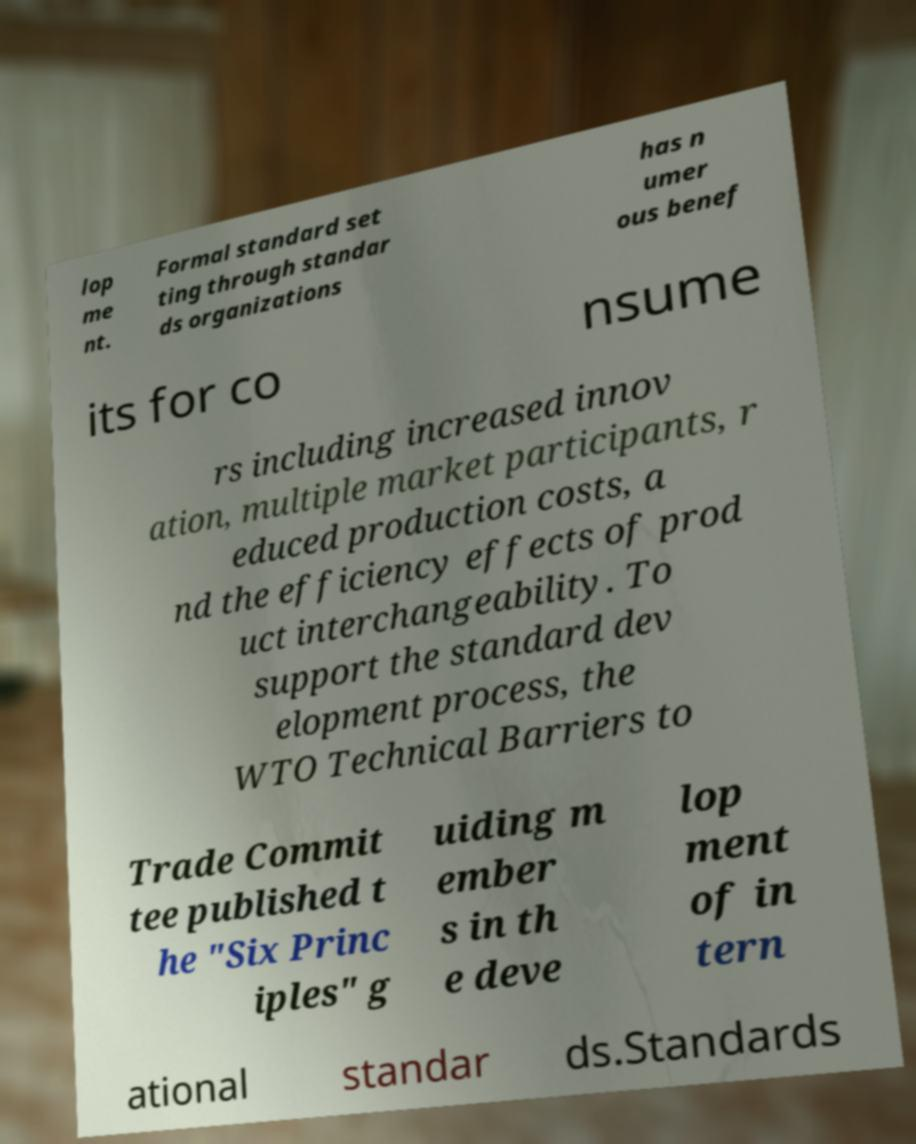I need the written content from this picture converted into text. Can you do that? lop me nt. Formal standard set ting through standar ds organizations has n umer ous benef its for co nsume rs including increased innov ation, multiple market participants, r educed production costs, a nd the efficiency effects of prod uct interchangeability. To support the standard dev elopment process, the WTO Technical Barriers to Trade Commit tee published t he "Six Princ iples" g uiding m ember s in th e deve lop ment of in tern ational standar ds.Standards 